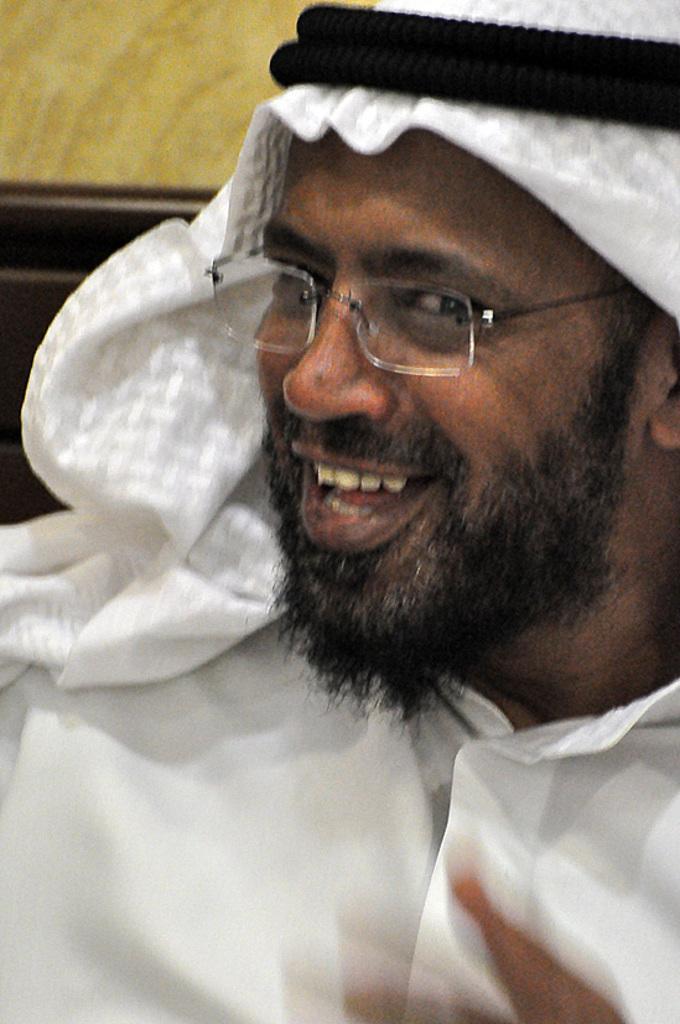Describe this image in one or two sentences. In the center of the image we can see a person is smiling and he is wearing glasses and he is in a different costume. In the background, we can see it is blurred. 